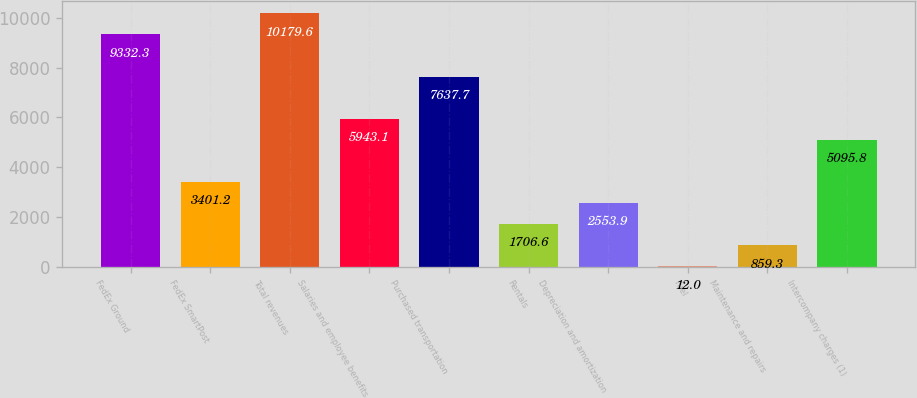<chart> <loc_0><loc_0><loc_500><loc_500><bar_chart><fcel>FedEx Ground<fcel>FedEx SmartPost<fcel>Total revenues<fcel>Salaries and employee benefits<fcel>Purchased transportation<fcel>Rentals<fcel>Depreciation and amortization<fcel>Fuel<fcel>Maintenance and repairs<fcel>Intercompany charges (1)<nl><fcel>9332.3<fcel>3401.2<fcel>10179.6<fcel>5943.1<fcel>7637.7<fcel>1706.6<fcel>2553.9<fcel>12<fcel>859.3<fcel>5095.8<nl></chart> 